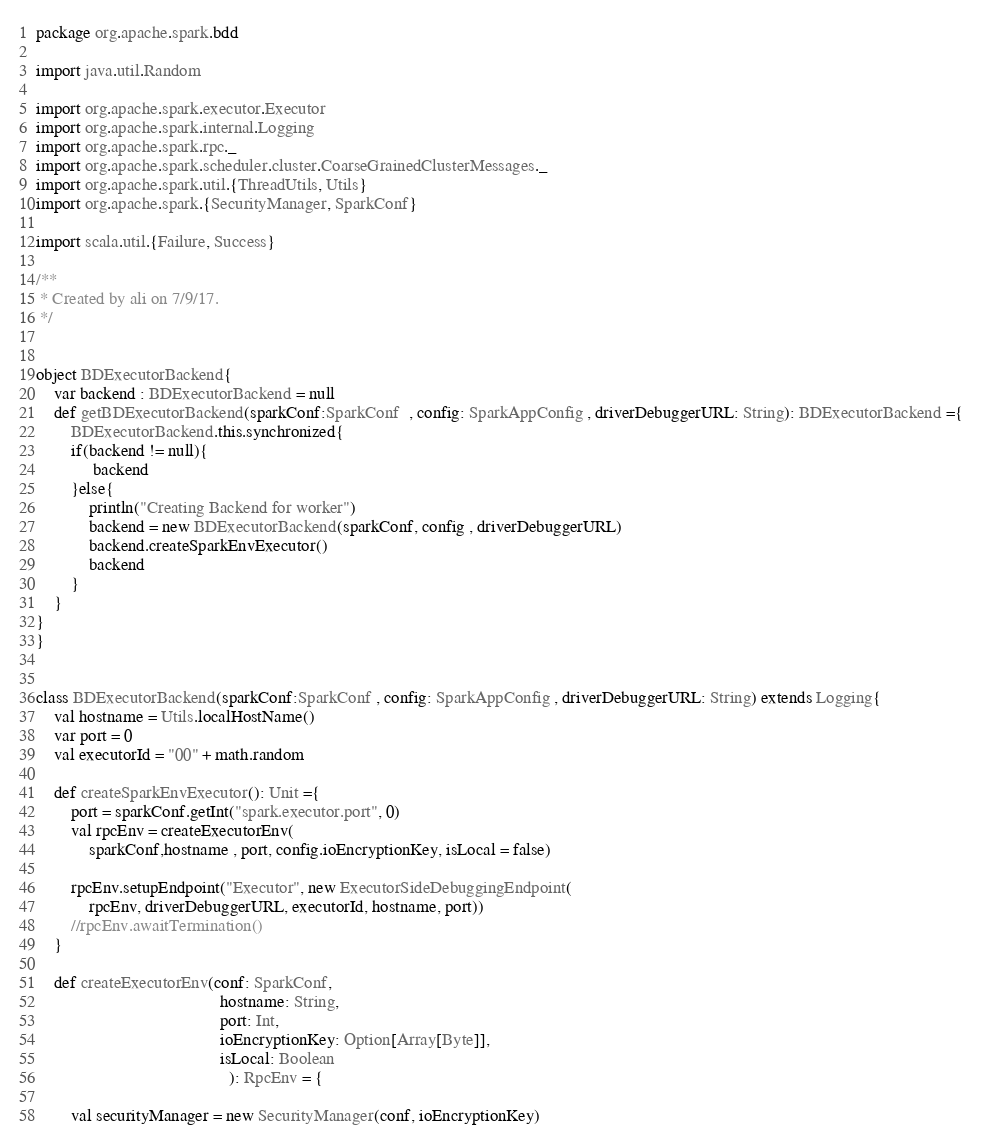<code> <loc_0><loc_0><loc_500><loc_500><_Scala_>package org.apache.spark.bdd

import java.util.Random

import org.apache.spark.executor.Executor
import org.apache.spark.internal.Logging
import org.apache.spark.rpc._
import org.apache.spark.scheduler.cluster.CoarseGrainedClusterMessages._
import org.apache.spark.util.{ThreadUtils, Utils}
import org.apache.spark.{SecurityManager, SparkConf}

import scala.util.{Failure, Success}

/**
 * Created by ali on 7/9/17.
 */


object BDExecutorBackend{
	var backend : BDExecutorBackend = null
	def getBDExecutorBackend(sparkConf:SparkConf  , config: SparkAppConfig , driverDebuggerURL: String): BDExecutorBackend ={
		BDExecutorBackend.this.synchronized{
		if(backend != null){
			 backend
		}else{
			println("Creating Backend for worker")
			backend = new BDExecutorBackend(sparkConf, config , driverDebuggerURL)
			backend.createSparkEnvExecutor()
			backend
		}
	}
}
}


class BDExecutorBackend(sparkConf:SparkConf , config: SparkAppConfig , driverDebuggerURL: String) extends Logging{
	val hostname = Utils.localHostName()
	var port = 0
	val executorId = "00" + math.random

	def createSparkEnvExecutor(): Unit ={
		port = sparkConf.getInt("spark.executor.port", 0)
		val rpcEnv = createExecutorEnv(
			sparkConf,hostname , port, config.ioEncryptionKey, isLocal = false)

		rpcEnv.setupEndpoint("Executor", new ExecutorSideDebuggingEndpoint(
			rpcEnv, driverDebuggerURL, executorId, hostname, port))
		//rpcEnv.awaitTermination()
	}
	
	def createExecutorEnv(conf: SparkConf,
		                                  hostname: String,
		                                  port: Int,
		                                  ioEncryptionKey: Option[Array[Byte]],
		                                  isLocal: Boolean
		                                    ): RpcEnv = {
		
		val securityManager = new SecurityManager(conf, ioEncryptionKey)</code> 